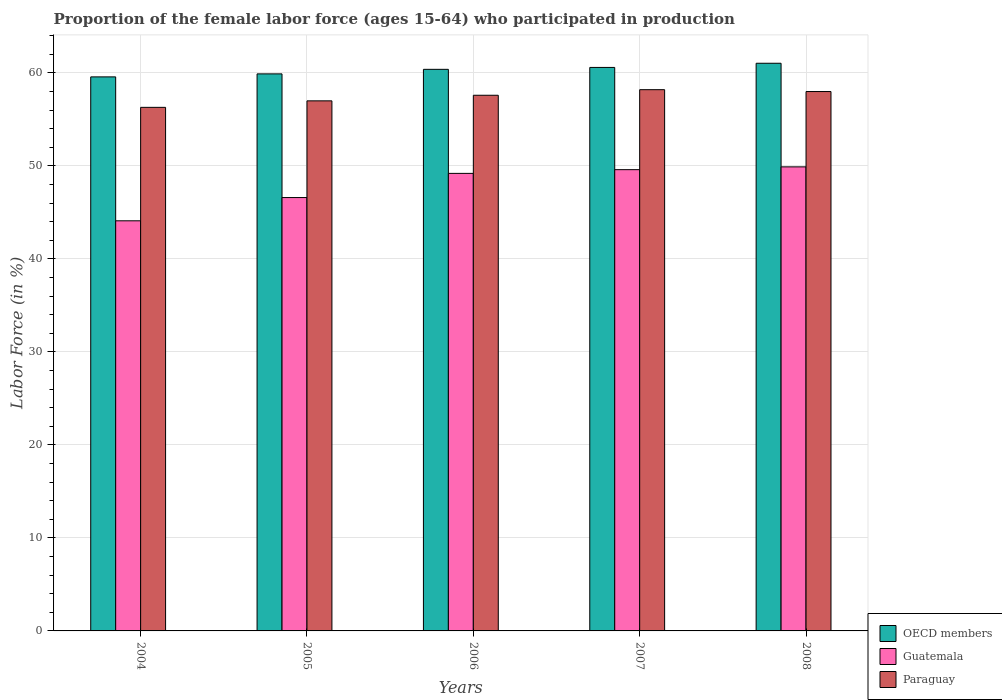How many different coloured bars are there?
Provide a succinct answer. 3. How many groups of bars are there?
Keep it short and to the point. 5. Are the number of bars on each tick of the X-axis equal?
Your answer should be compact. Yes. How many bars are there on the 5th tick from the left?
Offer a very short reply. 3. What is the label of the 5th group of bars from the left?
Your answer should be compact. 2008. What is the proportion of the female labor force who participated in production in OECD members in 2005?
Make the answer very short. 59.9. Across all years, what is the maximum proportion of the female labor force who participated in production in OECD members?
Your response must be concise. 61.04. Across all years, what is the minimum proportion of the female labor force who participated in production in Guatemala?
Your answer should be very brief. 44.1. In which year was the proportion of the female labor force who participated in production in Guatemala maximum?
Offer a terse response. 2008. In which year was the proportion of the female labor force who participated in production in OECD members minimum?
Ensure brevity in your answer.  2004. What is the total proportion of the female labor force who participated in production in OECD members in the graph?
Offer a terse response. 301.5. What is the difference between the proportion of the female labor force who participated in production in OECD members in 2007 and the proportion of the female labor force who participated in production in Paraguay in 2006?
Provide a succinct answer. 2.99. What is the average proportion of the female labor force who participated in production in OECD members per year?
Keep it short and to the point. 60.3. In the year 2007, what is the difference between the proportion of the female labor force who participated in production in OECD members and proportion of the female labor force who participated in production in Guatemala?
Keep it short and to the point. 10.99. In how many years, is the proportion of the female labor force who participated in production in OECD members greater than 2 %?
Provide a short and direct response. 5. What is the ratio of the proportion of the female labor force who participated in production in Paraguay in 2005 to that in 2008?
Offer a very short reply. 0.98. Is the proportion of the female labor force who participated in production in Guatemala in 2007 less than that in 2008?
Provide a short and direct response. Yes. What is the difference between the highest and the second highest proportion of the female labor force who participated in production in Paraguay?
Offer a terse response. 0.2. What is the difference between the highest and the lowest proportion of the female labor force who participated in production in OECD members?
Provide a short and direct response. 1.46. In how many years, is the proportion of the female labor force who participated in production in Guatemala greater than the average proportion of the female labor force who participated in production in Guatemala taken over all years?
Offer a terse response. 3. What does the 2nd bar from the right in 2008 represents?
Ensure brevity in your answer.  Guatemala. Is it the case that in every year, the sum of the proportion of the female labor force who participated in production in Guatemala and proportion of the female labor force who participated in production in Paraguay is greater than the proportion of the female labor force who participated in production in OECD members?
Your answer should be compact. Yes. Are all the bars in the graph horizontal?
Ensure brevity in your answer.  No. What is the difference between two consecutive major ticks on the Y-axis?
Offer a very short reply. 10. Are the values on the major ticks of Y-axis written in scientific E-notation?
Offer a very short reply. No. Where does the legend appear in the graph?
Provide a succinct answer. Bottom right. How many legend labels are there?
Your answer should be very brief. 3. What is the title of the graph?
Your response must be concise. Proportion of the female labor force (ages 15-64) who participated in production. Does "Guam" appear as one of the legend labels in the graph?
Keep it short and to the point. No. What is the Labor Force (in %) of OECD members in 2004?
Offer a very short reply. 59.58. What is the Labor Force (in %) of Guatemala in 2004?
Make the answer very short. 44.1. What is the Labor Force (in %) in Paraguay in 2004?
Ensure brevity in your answer.  56.3. What is the Labor Force (in %) of OECD members in 2005?
Offer a very short reply. 59.9. What is the Labor Force (in %) of Guatemala in 2005?
Offer a terse response. 46.6. What is the Labor Force (in %) in OECD members in 2006?
Your answer should be compact. 60.39. What is the Labor Force (in %) in Guatemala in 2006?
Provide a succinct answer. 49.2. What is the Labor Force (in %) in Paraguay in 2006?
Provide a short and direct response. 57.6. What is the Labor Force (in %) of OECD members in 2007?
Provide a succinct answer. 60.59. What is the Labor Force (in %) in Guatemala in 2007?
Offer a very short reply. 49.6. What is the Labor Force (in %) in Paraguay in 2007?
Your answer should be very brief. 58.2. What is the Labor Force (in %) in OECD members in 2008?
Your answer should be very brief. 61.04. What is the Labor Force (in %) in Guatemala in 2008?
Keep it short and to the point. 49.9. What is the Labor Force (in %) in Paraguay in 2008?
Offer a very short reply. 58. Across all years, what is the maximum Labor Force (in %) in OECD members?
Ensure brevity in your answer.  61.04. Across all years, what is the maximum Labor Force (in %) of Guatemala?
Your response must be concise. 49.9. Across all years, what is the maximum Labor Force (in %) in Paraguay?
Provide a short and direct response. 58.2. Across all years, what is the minimum Labor Force (in %) in OECD members?
Provide a succinct answer. 59.58. Across all years, what is the minimum Labor Force (in %) of Guatemala?
Your answer should be compact. 44.1. Across all years, what is the minimum Labor Force (in %) of Paraguay?
Offer a terse response. 56.3. What is the total Labor Force (in %) in OECD members in the graph?
Provide a succinct answer. 301.5. What is the total Labor Force (in %) in Guatemala in the graph?
Offer a very short reply. 239.4. What is the total Labor Force (in %) in Paraguay in the graph?
Keep it short and to the point. 287.1. What is the difference between the Labor Force (in %) in OECD members in 2004 and that in 2005?
Offer a very short reply. -0.32. What is the difference between the Labor Force (in %) in Guatemala in 2004 and that in 2005?
Your answer should be compact. -2.5. What is the difference between the Labor Force (in %) of OECD members in 2004 and that in 2006?
Provide a succinct answer. -0.81. What is the difference between the Labor Force (in %) of Paraguay in 2004 and that in 2006?
Your answer should be compact. -1.3. What is the difference between the Labor Force (in %) of OECD members in 2004 and that in 2007?
Your answer should be very brief. -1.02. What is the difference between the Labor Force (in %) of Guatemala in 2004 and that in 2007?
Keep it short and to the point. -5.5. What is the difference between the Labor Force (in %) of Paraguay in 2004 and that in 2007?
Offer a terse response. -1.9. What is the difference between the Labor Force (in %) in OECD members in 2004 and that in 2008?
Keep it short and to the point. -1.46. What is the difference between the Labor Force (in %) of Guatemala in 2004 and that in 2008?
Your answer should be very brief. -5.8. What is the difference between the Labor Force (in %) of Paraguay in 2004 and that in 2008?
Offer a very short reply. -1.7. What is the difference between the Labor Force (in %) of OECD members in 2005 and that in 2006?
Make the answer very short. -0.49. What is the difference between the Labor Force (in %) of Guatemala in 2005 and that in 2006?
Your response must be concise. -2.6. What is the difference between the Labor Force (in %) in Paraguay in 2005 and that in 2006?
Provide a short and direct response. -0.6. What is the difference between the Labor Force (in %) of OECD members in 2005 and that in 2007?
Your answer should be compact. -0.69. What is the difference between the Labor Force (in %) of Paraguay in 2005 and that in 2007?
Keep it short and to the point. -1.2. What is the difference between the Labor Force (in %) of OECD members in 2005 and that in 2008?
Provide a succinct answer. -1.14. What is the difference between the Labor Force (in %) in OECD members in 2006 and that in 2007?
Provide a short and direct response. -0.2. What is the difference between the Labor Force (in %) in OECD members in 2006 and that in 2008?
Your response must be concise. -0.65. What is the difference between the Labor Force (in %) in OECD members in 2007 and that in 2008?
Keep it short and to the point. -0.45. What is the difference between the Labor Force (in %) of OECD members in 2004 and the Labor Force (in %) of Guatemala in 2005?
Provide a succinct answer. 12.98. What is the difference between the Labor Force (in %) of OECD members in 2004 and the Labor Force (in %) of Paraguay in 2005?
Your answer should be compact. 2.58. What is the difference between the Labor Force (in %) of Guatemala in 2004 and the Labor Force (in %) of Paraguay in 2005?
Offer a terse response. -12.9. What is the difference between the Labor Force (in %) of OECD members in 2004 and the Labor Force (in %) of Guatemala in 2006?
Your answer should be very brief. 10.38. What is the difference between the Labor Force (in %) of OECD members in 2004 and the Labor Force (in %) of Paraguay in 2006?
Offer a very short reply. 1.98. What is the difference between the Labor Force (in %) of OECD members in 2004 and the Labor Force (in %) of Guatemala in 2007?
Your answer should be compact. 9.98. What is the difference between the Labor Force (in %) in OECD members in 2004 and the Labor Force (in %) in Paraguay in 2007?
Your answer should be compact. 1.38. What is the difference between the Labor Force (in %) of Guatemala in 2004 and the Labor Force (in %) of Paraguay in 2007?
Ensure brevity in your answer.  -14.1. What is the difference between the Labor Force (in %) in OECD members in 2004 and the Labor Force (in %) in Guatemala in 2008?
Give a very brief answer. 9.68. What is the difference between the Labor Force (in %) in OECD members in 2004 and the Labor Force (in %) in Paraguay in 2008?
Make the answer very short. 1.58. What is the difference between the Labor Force (in %) in Guatemala in 2004 and the Labor Force (in %) in Paraguay in 2008?
Keep it short and to the point. -13.9. What is the difference between the Labor Force (in %) of OECD members in 2005 and the Labor Force (in %) of Guatemala in 2006?
Give a very brief answer. 10.7. What is the difference between the Labor Force (in %) of OECD members in 2005 and the Labor Force (in %) of Paraguay in 2006?
Your answer should be compact. 2.3. What is the difference between the Labor Force (in %) of OECD members in 2005 and the Labor Force (in %) of Guatemala in 2007?
Your response must be concise. 10.3. What is the difference between the Labor Force (in %) in OECD members in 2005 and the Labor Force (in %) in Paraguay in 2007?
Offer a terse response. 1.7. What is the difference between the Labor Force (in %) of OECD members in 2005 and the Labor Force (in %) of Guatemala in 2008?
Provide a succinct answer. 10. What is the difference between the Labor Force (in %) in OECD members in 2005 and the Labor Force (in %) in Paraguay in 2008?
Your response must be concise. 1.9. What is the difference between the Labor Force (in %) in OECD members in 2006 and the Labor Force (in %) in Guatemala in 2007?
Offer a terse response. 10.79. What is the difference between the Labor Force (in %) in OECD members in 2006 and the Labor Force (in %) in Paraguay in 2007?
Provide a short and direct response. 2.19. What is the difference between the Labor Force (in %) in Guatemala in 2006 and the Labor Force (in %) in Paraguay in 2007?
Offer a terse response. -9. What is the difference between the Labor Force (in %) of OECD members in 2006 and the Labor Force (in %) of Guatemala in 2008?
Ensure brevity in your answer.  10.49. What is the difference between the Labor Force (in %) in OECD members in 2006 and the Labor Force (in %) in Paraguay in 2008?
Keep it short and to the point. 2.39. What is the difference between the Labor Force (in %) in Guatemala in 2006 and the Labor Force (in %) in Paraguay in 2008?
Ensure brevity in your answer.  -8.8. What is the difference between the Labor Force (in %) in OECD members in 2007 and the Labor Force (in %) in Guatemala in 2008?
Offer a very short reply. 10.69. What is the difference between the Labor Force (in %) of OECD members in 2007 and the Labor Force (in %) of Paraguay in 2008?
Your response must be concise. 2.59. What is the difference between the Labor Force (in %) of Guatemala in 2007 and the Labor Force (in %) of Paraguay in 2008?
Offer a very short reply. -8.4. What is the average Labor Force (in %) in OECD members per year?
Your answer should be compact. 60.3. What is the average Labor Force (in %) of Guatemala per year?
Your answer should be very brief. 47.88. What is the average Labor Force (in %) in Paraguay per year?
Offer a terse response. 57.42. In the year 2004, what is the difference between the Labor Force (in %) of OECD members and Labor Force (in %) of Guatemala?
Your response must be concise. 15.48. In the year 2004, what is the difference between the Labor Force (in %) of OECD members and Labor Force (in %) of Paraguay?
Make the answer very short. 3.28. In the year 2005, what is the difference between the Labor Force (in %) in OECD members and Labor Force (in %) in Guatemala?
Give a very brief answer. 13.3. In the year 2005, what is the difference between the Labor Force (in %) in OECD members and Labor Force (in %) in Paraguay?
Ensure brevity in your answer.  2.9. In the year 2005, what is the difference between the Labor Force (in %) of Guatemala and Labor Force (in %) of Paraguay?
Provide a short and direct response. -10.4. In the year 2006, what is the difference between the Labor Force (in %) of OECD members and Labor Force (in %) of Guatemala?
Your answer should be compact. 11.19. In the year 2006, what is the difference between the Labor Force (in %) of OECD members and Labor Force (in %) of Paraguay?
Ensure brevity in your answer.  2.79. In the year 2007, what is the difference between the Labor Force (in %) in OECD members and Labor Force (in %) in Guatemala?
Offer a terse response. 10.99. In the year 2007, what is the difference between the Labor Force (in %) of OECD members and Labor Force (in %) of Paraguay?
Your answer should be compact. 2.39. In the year 2008, what is the difference between the Labor Force (in %) of OECD members and Labor Force (in %) of Guatemala?
Your response must be concise. 11.14. In the year 2008, what is the difference between the Labor Force (in %) in OECD members and Labor Force (in %) in Paraguay?
Your response must be concise. 3.04. In the year 2008, what is the difference between the Labor Force (in %) of Guatemala and Labor Force (in %) of Paraguay?
Your response must be concise. -8.1. What is the ratio of the Labor Force (in %) of Guatemala in 2004 to that in 2005?
Your answer should be very brief. 0.95. What is the ratio of the Labor Force (in %) of Paraguay in 2004 to that in 2005?
Ensure brevity in your answer.  0.99. What is the ratio of the Labor Force (in %) in OECD members in 2004 to that in 2006?
Your answer should be very brief. 0.99. What is the ratio of the Labor Force (in %) in Guatemala in 2004 to that in 2006?
Your response must be concise. 0.9. What is the ratio of the Labor Force (in %) of Paraguay in 2004 to that in 2006?
Offer a terse response. 0.98. What is the ratio of the Labor Force (in %) in OECD members in 2004 to that in 2007?
Your answer should be compact. 0.98. What is the ratio of the Labor Force (in %) in Guatemala in 2004 to that in 2007?
Your answer should be compact. 0.89. What is the ratio of the Labor Force (in %) of Paraguay in 2004 to that in 2007?
Your response must be concise. 0.97. What is the ratio of the Labor Force (in %) of OECD members in 2004 to that in 2008?
Your response must be concise. 0.98. What is the ratio of the Labor Force (in %) of Guatemala in 2004 to that in 2008?
Offer a very short reply. 0.88. What is the ratio of the Labor Force (in %) in Paraguay in 2004 to that in 2008?
Your answer should be very brief. 0.97. What is the ratio of the Labor Force (in %) of OECD members in 2005 to that in 2006?
Offer a terse response. 0.99. What is the ratio of the Labor Force (in %) of Guatemala in 2005 to that in 2006?
Your answer should be very brief. 0.95. What is the ratio of the Labor Force (in %) of OECD members in 2005 to that in 2007?
Make the answer very short. 0.99. What is the ratio of the Labor Force (in %) in Guatemala in 2005 to that in 2007?
Make the answer very short. 0.94. What is the ratio of the Labor Force (in %) of Paraguay in 2005 to that in 2007?
Provide a succinct answer. 0.98. What is the ratio of the Labor Force (in %) of OECD members in 2005 to that in 2008?
Keep it short and to the point. 0.98. What is the ratio of the Labor Force (in %) of Guatemala in 2005 to that in 2008?
Keep it short and to the point. 0.93. What is the ratio of the Labor Force (in %) of Paraguay in 2005 to that in 2008?
Offer a terse response. 0.98. What is the ratio of the Labor Force (in %) in OECD members in 2006 to that in 2007?
Give a very brief answer. 1. What is the ratio of the Labor Force (in %) in Guatemala in 2006 to that in 2007?
Your response must be concise. 0.99. What is the ratio of the Labor Force (in %) in OECD members in 2006 to that in 2008?
Your response must be concise. 0.99. What is the ratio of the Labor Force (in %) in Guatemala in 2006 to that in 2008?
Your answer should be compact. 0.99. What is the ratio of the Labor Force (in %) of OECD members in 2007 to that in 2008?
Give a very brief answer. 0.99. What is the difference between the highest and the second highest Labor Force (in %) in OECD members?
Provide a short and direct response. 0.45. What is the difference between the highest and the second highest Labor Force (in %) in Guatemala?
Your answer should be very brief. 0.3. What is the difference between the highest and the second highest Labor Force (in %) in Paraguay?
Provide a succinct answer. 0.2. What is the difference between the highest and the lowest Labor Force (in %) of OECD members?
Your answer should be very brief. 1.46. What is the difference between the highest and the lowest Labor Force (in %) of Paraguay?
Offer a terse response. 1.9. 